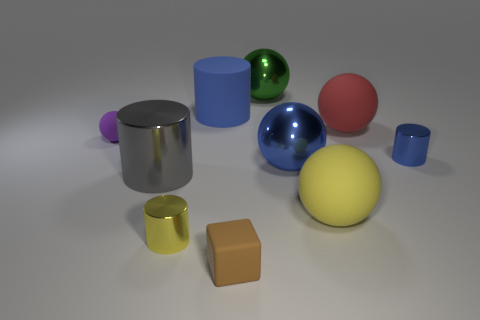Are there any other things that have the same size as the brown object?
Offer a very short reply. Yes. What material is the large thing that is the same color as the big rubber cylinder?
Keep it short and to the point. Metal. There is a green object that is the same shape as the large red thing; what is its material?
Provide a succinct answer. Metal. Is the shape of the large blue thing that is on the right side of the brown rubber block the same as the tiny matte thing on the left side of the yellow metal cylinder?
Make the answer very short. Yes. There is a large yellow object that is made of the same material as the red sphere; what is its shape?
Offer a terse response. Sphere. What color is the small object that is to the right of the matte cylinder and left of the big green sphere?
Your answer should be very brief. Brown. Does the large blue object that is behind the red object have the same material as the large green object?
Keep it short and to the point. No. Are there fewer small blue metallic cylinders to the left of the tiny purple thing than brown blocks?
Provide a short and direct response. Yes. Are there any small green cylinders that have the same material as the large gray cylinder?
Provide a short and direct response. No. There is a matte block; is its size the same as the metal cylinder that is to the right of the brown object?
Your response must be concise. Yes. 